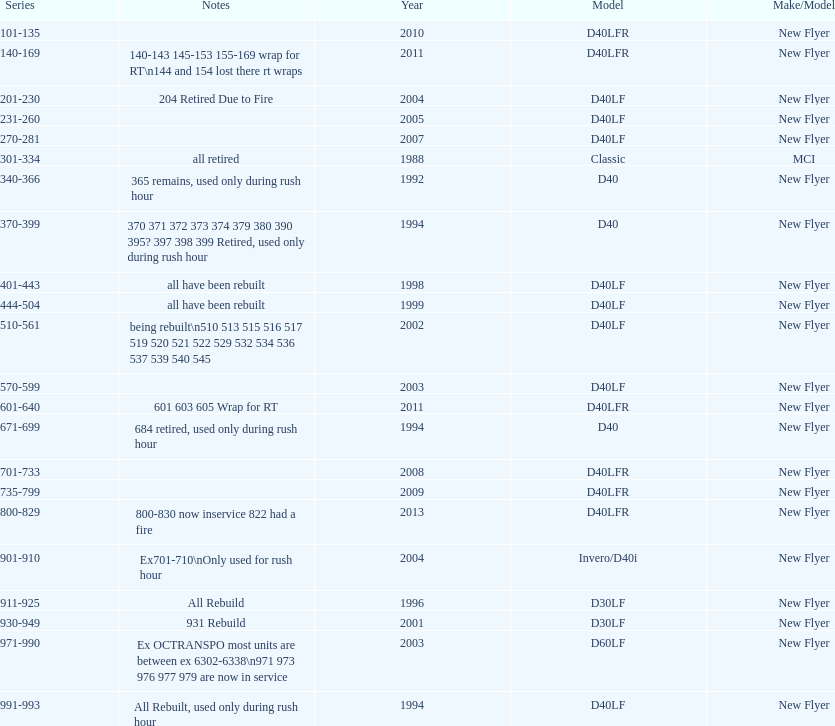Which buses are the newest in the current fleet? 800-829. 